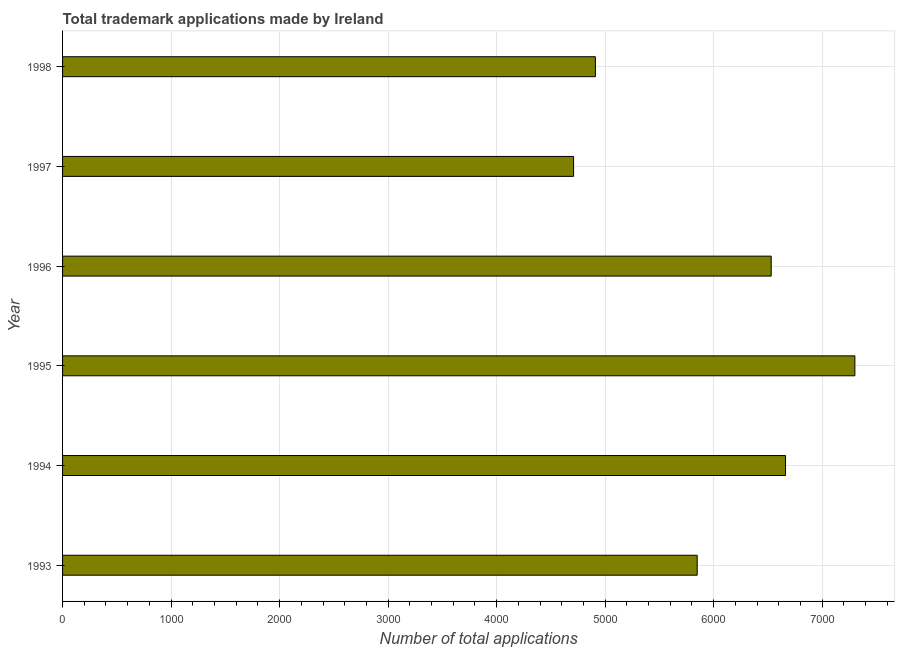Does the graph contain any zero values?
Ensure brevity in your answer.  No. Does the graph contain grids?
Your answer should be very brief. Yes. What is the title of the graph?
Give a very brief answer. Total trademark applications made by Ireland. What is the label or title of the X-axis?
Offer a very short reply. Number of total applications. What is the label or title of the Y-axis?
Keep it short and to the point. Year. What is the number of trademark applications in 1996?
Provide a succinct answer. 6530. Across all years, what is the maximum number of trademark applications?
Give a very brief answer. 7301. Across all years, what is the minimum number of trademark applications?
Your response must be concise. 4709. In which year was the number of trademark applications maximum?
Keep it short and to the point. 1995. In which year was the number of trademark applications minimum?
Keep it short and to the point. 1997. What is the sum of the number of trademark applications?
Offer a terse response. 3.60e+04. What is the difference between the number of trademark applications in 1994 and 1998?
Your answer should be very brief. 1752. What is the average number of trademark applications per year?
Your answer should be compact. 5993. What is the median number of trademark applications?
Keep it short and to the point. 6189. Do a majority of the years between 1998 and 1995 (inclusive) have number of trademark applications greater than 1800 ?
Ensure brevity in your answer.  Yes. What is the ratio of the number of trademark applications in 1995 to that in 1996?
Provide a succinct answer. 1.12. Is the number of trademark applications in 1994 less than that in 1995?
Keep it short and to the point. Yes. Is the difference between the number of trademark applications in 1993 and 1995 greater than the difference between any two years?
Offer a very short reply. No. What is the difference between the highest and the second highest number of trademark applications?
Provide a succinct answer. 639. What is the difference between the highest and the lowest number of trademark applications?
Give a very brief answer. 2592. In how many years, is the number of trademark applications greater than the average number of trademark applications taken over all years?
Provide a short and direct response. 3. How many bars are there?
Provide a short and direct response. 6. How many years are there in the graph?
Your answer should be very brief. 6. What is the difference between two consecutive major ticks on the X-axis?
Your answer should be very brief. 1000. Are the values on the major ticks of X-axis written in scientific E-notation?
Give a very brief answer. No. What is the Number of total applications of 1993?
Give a very brief answer. 5848. What is the Number of total applications in 1994?
Your answer should be compact. 6662. What is the Number of total applications of 1995?
Ensure brevity in your answer.  7301. What is the Number of total applications in 1996?
Offer a very short reply. 6530. What is the Number of total applications in 1997?
Your answer should be compact. 4709. What is the Number of total applications of 1998?
Make the answer very short. 4910. What is the difference between the Number of total applications in 1993 and 1994?
Provide a succinct answer. -814. What is the difference between the Number of total applications in 1993 and 1995?
Your response must be concise. -1453. What is the difference between the Number of total applications in 1993 and 1996?
Make the answer very short. -682. What is the difference between the Number of total applications in 1993 and 1997?
Your response must be concise. 1139. What is the difference between the Number of total applications in 1993 and 1998?
Ensure brevity in your answer.  938. What is the difference between the Number of total applications in 1994 and 1995?
Make the answer very short. -639. What is the difference between the Number of total applications in 1994 and 1996?
Keep it short and to the point. 132. What is the difference between the Number of total applications in 1994 and 1997?
Offer a terse response. 1953. What is the difference between the Number of total applications in 1994 and 1998?
Offer a terse response. 1752. What is the difference between the Number of total applications in 1995 and 1996?
Keep it short and to the point. 771. What is the difference between the Number of total applications in 1995 and 1997?
Ensure brevity in your answer.  2592. What is the difference between the Number of total applications in 1995 and 1998?
Offer a very short reply. 2391. What is the difference between the Number of total applications in 1996 and 1997?
Provide a succinct answer. 1821. What is the difference between the Number of total applications in 1996 and 1998?
Provide a succinct answer. 1620. What is the difference between the Number of total applications in 1997 and 1998?
Your answer should be compact. -201. What is the ratio of the Number of total applications in 1993 to that in 1994?
Offer a terse response. 0.88. What is the ratio of the Number of total applications in 1993 to that in 1995?
Make the answer very short. 0.8. What is the ratio of the Number of total applications in 1993 to that in 1996?
Ensure brevity in your answer.  0.9. What is the ratio of the Number of total applications in 1993 to that in 1997?
Keep it short and to the point. 1.24. What is the ratio of the Number of total applications in 1993 to that in 1998?
Ensure brevity in your answer.  1.19. What is the ratio of the Number of total applications in 1994 to that in 1995?
Your answer should be compact. 0.91. What is the ratio of the Number of total applications in 1994 to that in 1997?
Your response must be concise. 1.42. What is the ratio of the Number of total applications in 1994 to that in 1998?
Offer a terse response. 1.36. What is the ratio of the Number of total applications in 1995 to that in 1996?
Your response must be concise. 1.12. What is the ratio of the Number of total applications in 1995 to that in 1997?
Give a very brief answer. 1.55. What is the ratio of the Number of total applications in 1995 to that in 1998?
Offer a very short reply. 1.49. What is the ratio of the Number of total applications in 1996 to that in 1997?
Keep it short and to the point. 1.39. What is the ratio of the Number of total applications in 1996 to that in 1998?
Provide a succinct answer. 1.33. What is the ratio of the Number of total applications in 1997 to that in 1998?
Offer a very short reply. 0.96. 